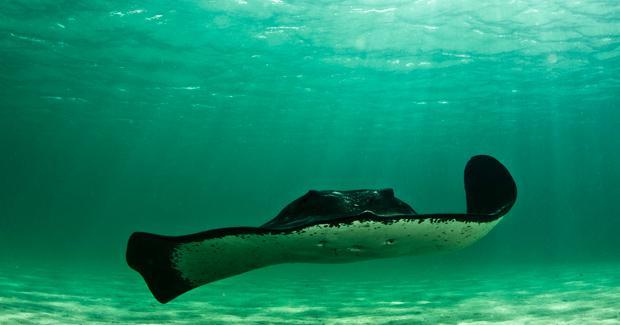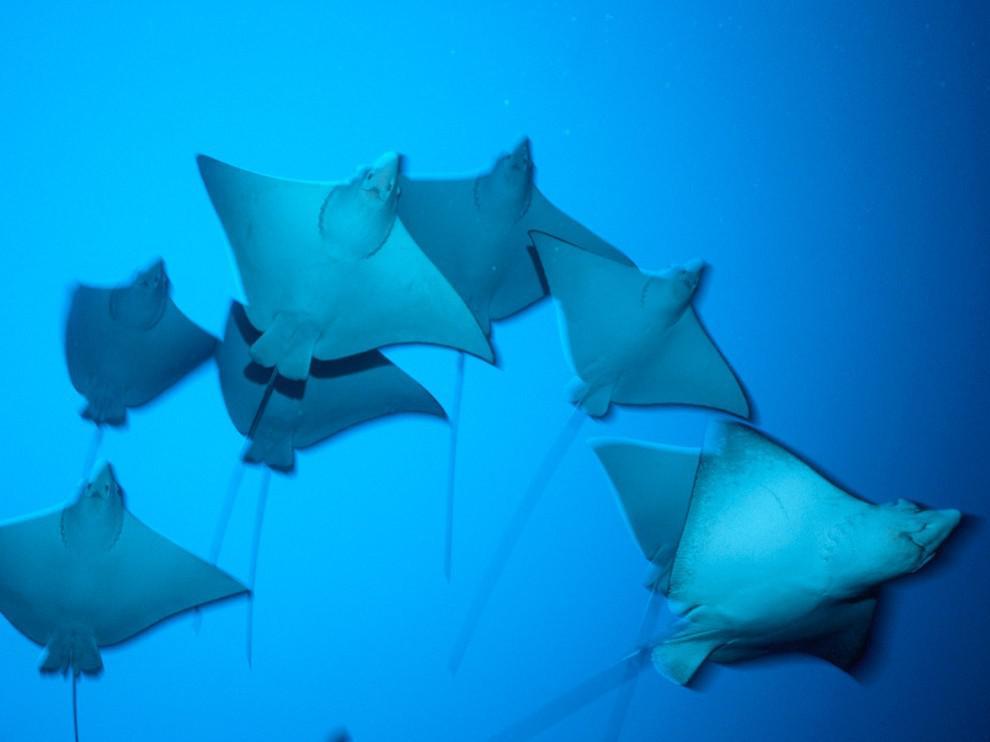The first image is the image on the left, the second image is the image on the right. Evaluate the accuracy of this statement regarding the images: "Each images shows just one stingray in the foreground.". Is it true? Answer yes or no. No. The first image is the image on the left, the second image is the image on the right. Considering the images on both sides, is "At least three sting rays are swimming in the water." valid? Answer yes or no. Yes. 